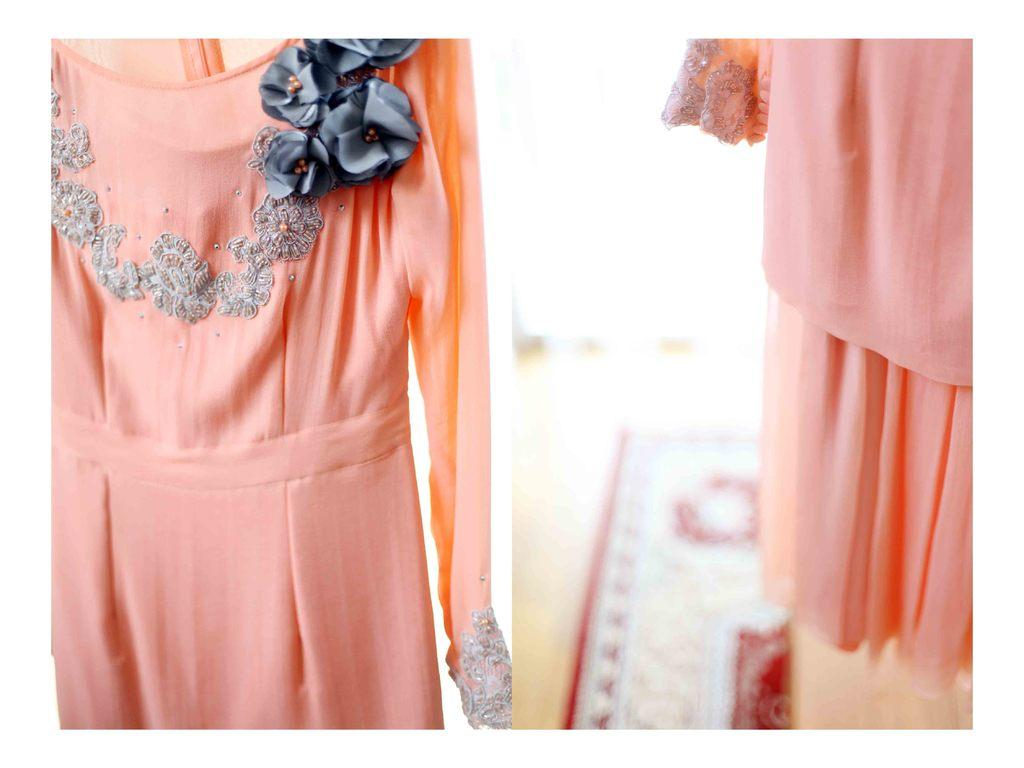What type of clothing items are hanging in the image? There are two pink dresses hanging in the image. What is on the floor in the image? There is a carpet on the floor in the image. What type of rabbit can be seen hopping on the scale in the image? There is no rabbit or scale present in the image; it only features two pink dresses hanging and a carpet on the floor. 